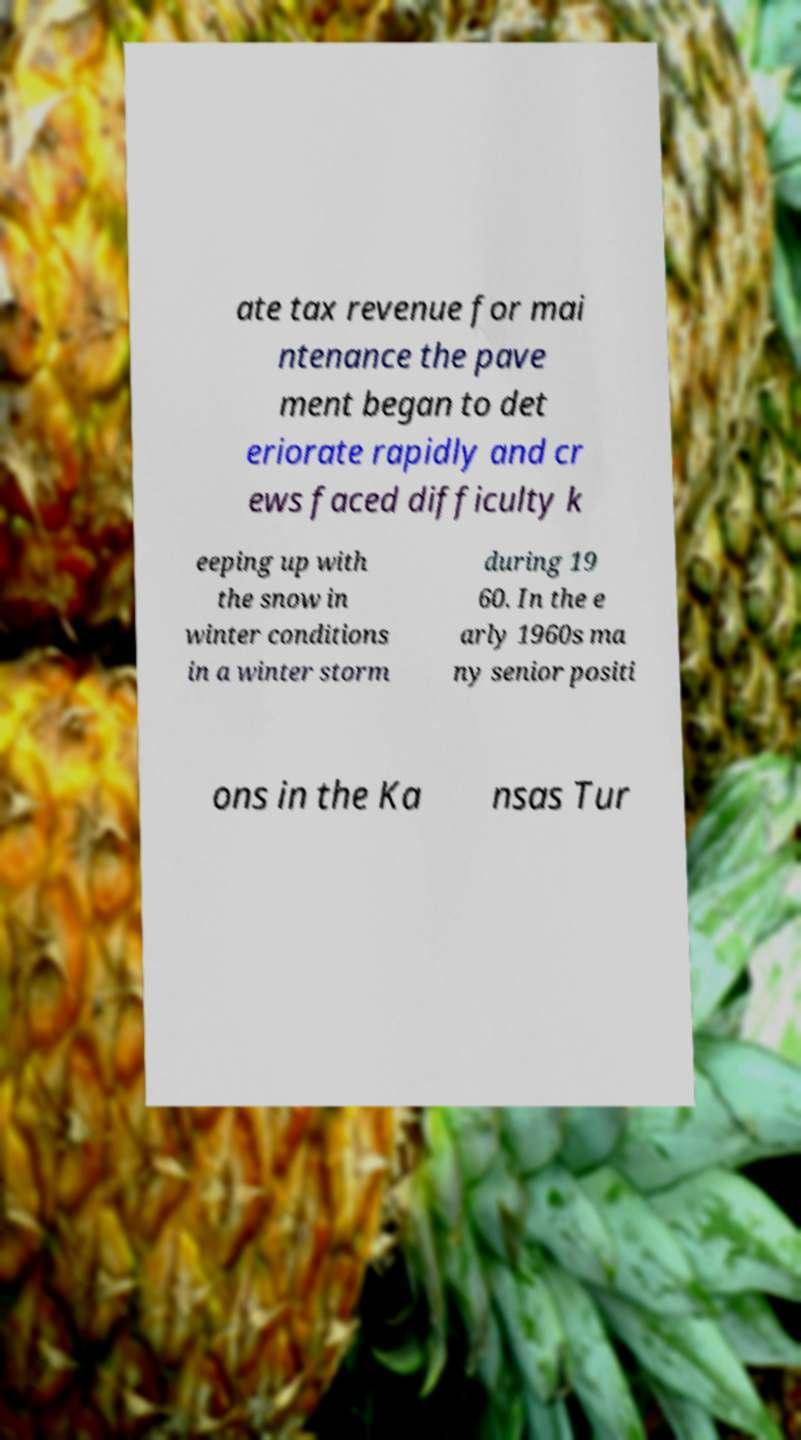Please read and relay the text visible in this image. What does it say? ate tax revenue for mai ntenance the pave ment began to det eriorate rapidly and cr ews faced difficulty k eeping up with the snow in winter conditions in a winter storm during 19 60. In the e arly 1960s ma ny senior positi ons in the Ka nsas Tur 